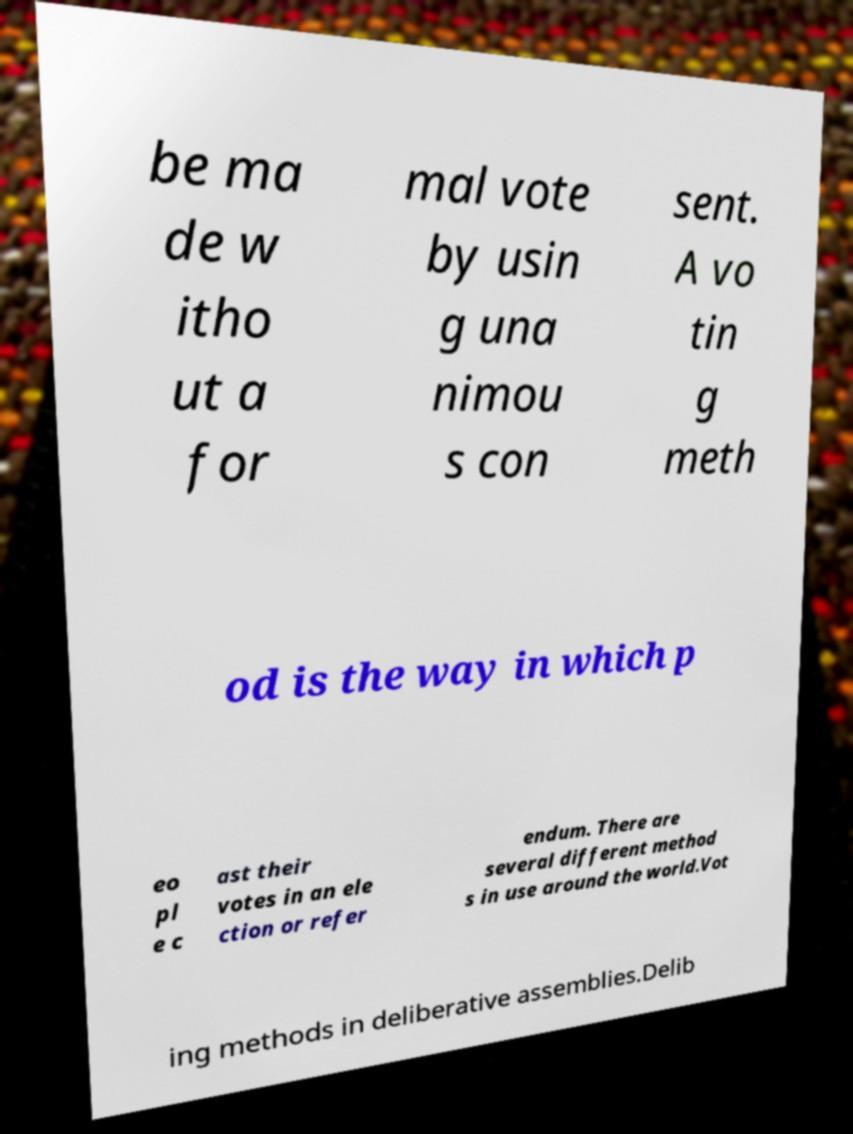Can you read and provide the text displayed in the image?This photo seems to have some interesting text. Can you extract and type it out for me? be ma de w itho ut a for mal vote by usin g una nimou s con sent. A vo tin g meth od is the way in which p eo pl e c ast their votes in an ele ction or refer endum. There are several different method s in use around the world.Vot ing methods in deliberative assemblies.Delib 